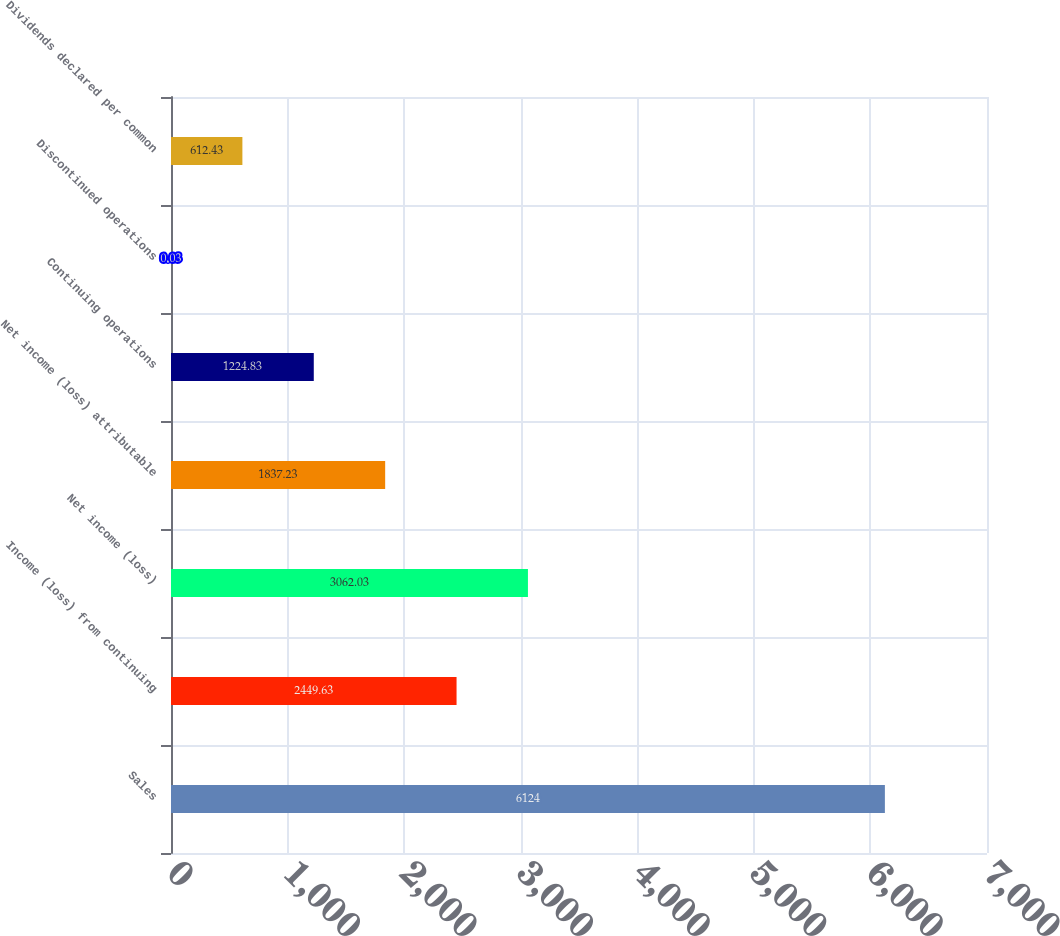Convert chart. <chart><loc_0><loc_0><loc_500><loc_500><bar_chart><fcel>Sales<fcel>Income (loss) from continuing<fcel>Net income (loss)<fcel>Net income (loss) attributable<fcel>Continuing operations<fcel>Discontinued operations<fcel>Dividends declared per common<nl><fcel>6124<fcel>2449.63<fcel>3062.03<fcel>1837.23<fcel>1224.83<fcel>0.03<fcel>612.43<nl></chart> 